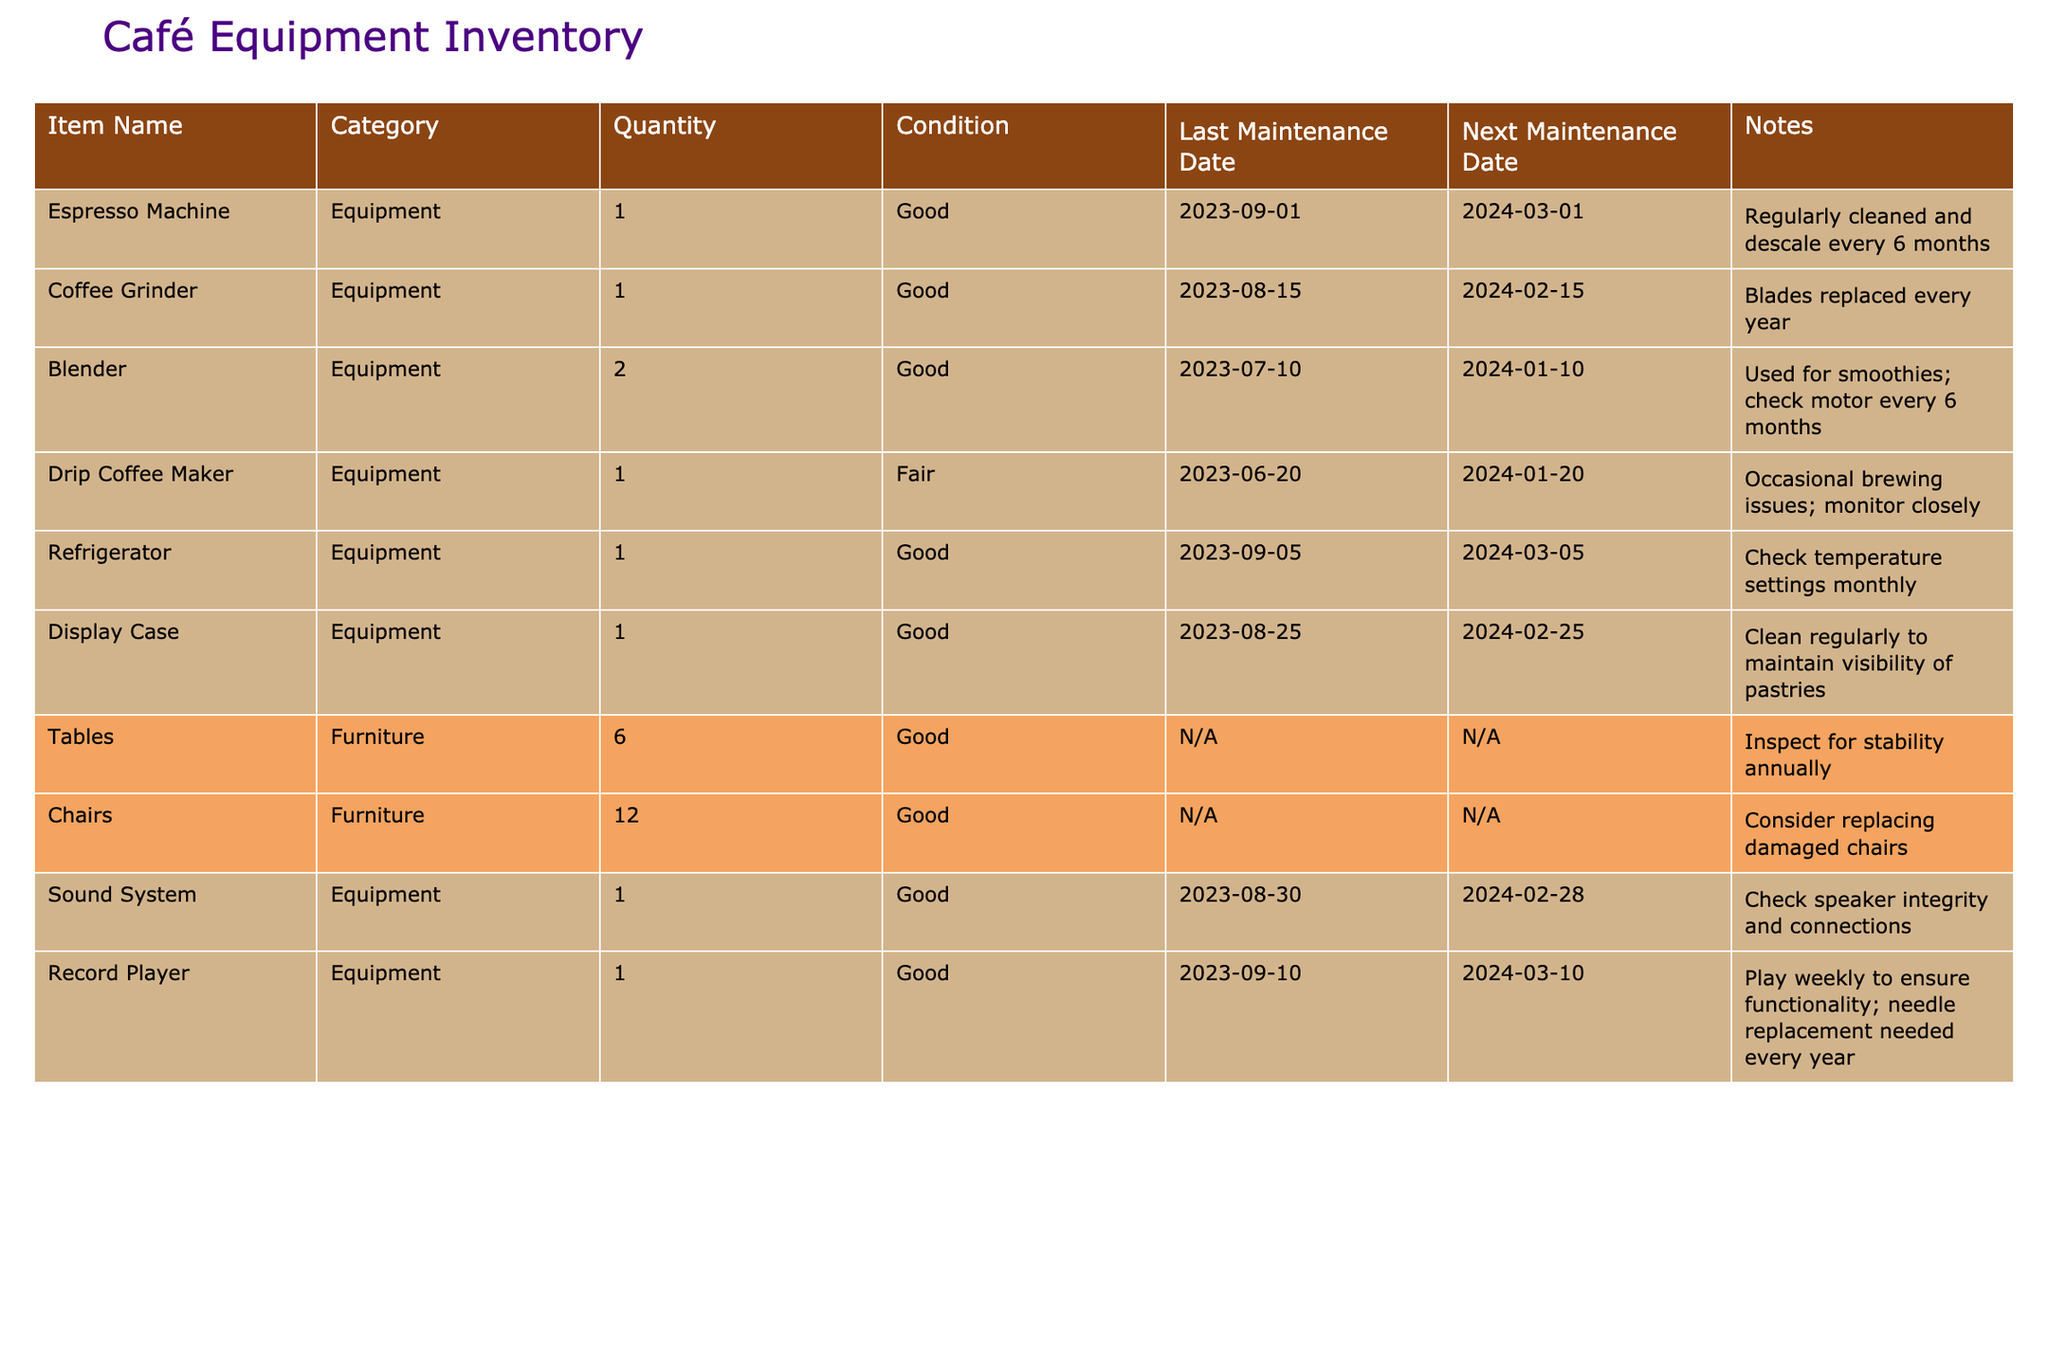What is the condition of the Coffee Grinder? The condition of the Coffee Grinder can be found in the "Condition" column next to its name in the table. It states that the condition is "Good."
Answer: Good When was the last maintenance performed on the Espresso Machine? The last maintenance date for the Espresso Machine is listed in the "Last Maintenance Date" column. According to the table, it was last maintained on 2023-09-01.
Answer: 2023-09-01 How many pieces of equipment are scheduled for maintenance in February 2024? To find the total pieces of equipment scheduled for maintenance in February 2024, we look at the "Next Maintenance Date" column and count the occurrences of entries in February 2024. There are four items: the Coffee Grinder, Blender, Sound System, and Record Player.
Answer: 4 Is the Drip Coffee Maker functioning properly? The table indicates that the Drip Coffee Maker is in "Fair" condition and has brewing issues. Thus, it suggests that it may not be functioning properly at times, requiring close monitoring.
Answer: No What is the difference between the quantity of Chairs and Tables in inventory? The quantity of Chairs is 12, and the quantity of Tables is 6. The difference is calculated as 12 (Chairs) - 6 (Tables) = 6.
Answer: 6 When is the next maintenance for the Blender? The "Next Maintenance Date" column lists the next maintenance date for the Blender as 2024-01-10.
Answer: 2024-01-10 Which equipment requires needle replacement every year? The table notes that the Record Player needs needle replacement every year as a part of its maintenance. This can be found in the "Notes" column next to the Record Player entry.
Answer: Record Player How many items in the inventory are categorized as Furniture? The table lists two categories: Equipment and Furniture. By counting the "Furniture" entries, we find there are 6 tables and 12 chairs, totaling to 2 Furniture items.
Answer: 2 What maintenance needs to be performed on the Sound System, and when? The Sound System requires checking the speaker integrity and connections. According to the "Next Maintenance Date," this is scheduled for 2024-02-28.
Answer: Check speakers by 2024-02-28 